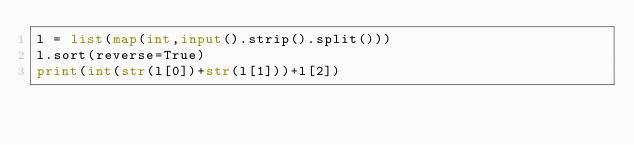Convert code to text. <code><loc_0><loc_0><loc_500><loc_500><_Python_>l = list(map(int,input().strip().split()))
l.sort(reverse=True)
print(int(str(l[0])+str(l[1]))+l[2])</code> 